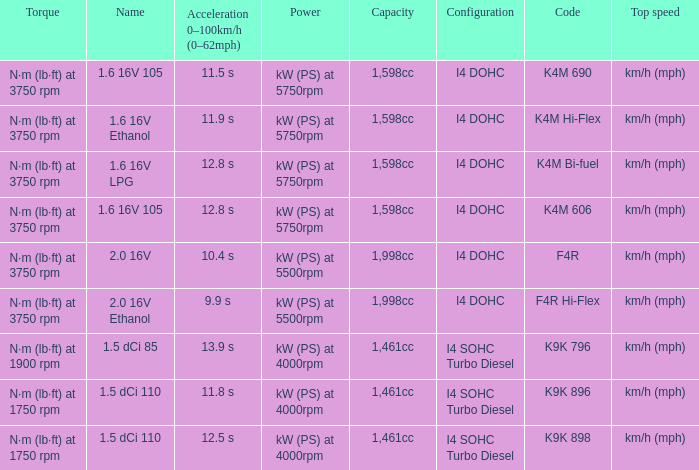What is the code of 1.5 dci 110, which has a capacity of 1,461cc? K9K 896, K9K 898. 